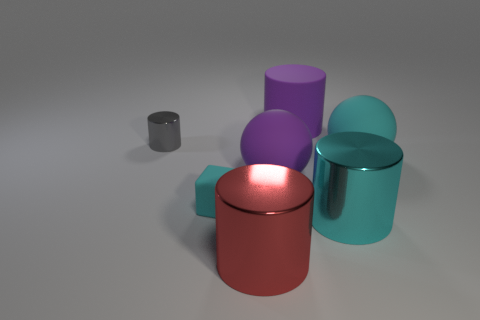Add 3 large red shiny objects. How many objects exist? 10 Subtract all shiny cylinders. How many cylinders are left? 1 Subtract all cubes. How many objects are left? 6 Subtract 1 cyan balls. How many objects are left? 6 Subtract 1 blocks. How many blocks are left? 0 Subtract all purple spheres. Subtract all blue cubes. How many spheres are left? 1 Subtract all gray balls. How many yellow blocks are left? 0 Subtract all purple metallic things. Subtract all purple matte cylinders. How many objects are left? 6 Add 7 tiny rubber things. How many tiny rubber things are left? 8 Add 7 yellow things. How many yellow things exist? 7 